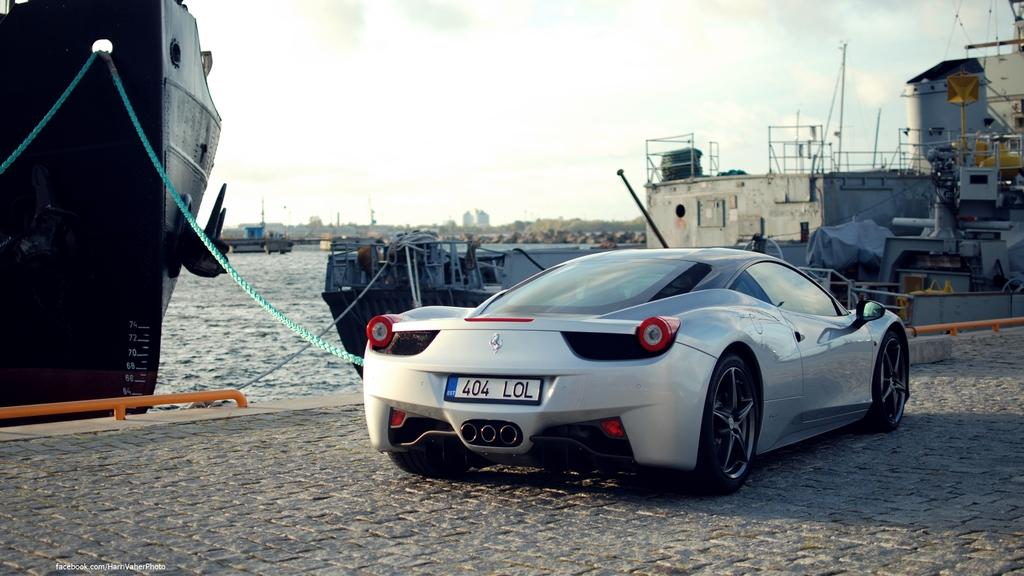What type of vehicle is on the right side of the image? There is a gray color vehicle on the right side of the image. Where is the vehicle located? The vehicle is on a road. What can be seen in the background of the image? In the background of the image, there are ships and boats on the water, trees, buildings, and clouds in the sky. How many legs does the vehicle have in the image? Vehicles do not have legs; they have wheels. In this image, the vehicle has four wheels. 